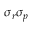<formula> <loc_0><loc_0><loc_500><loc_500>\sigma _ { r } \sigma _ { p }</formula> 